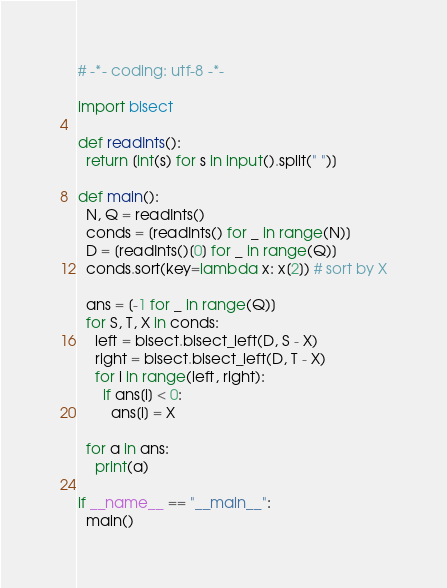Convert code to text. <code><loc_0><loc_0><loc_500><loc_500><_Python_># -*- coding: utf-8 -*-

import bisect

def readInts():
  return [int(s) for s in input().split(" ")]

def main():
  N, Q = readInts()
  conds = [readInts() for _ in range(N)]
  D = [readInts()[0] for _ in range(Q)]
  conds.sort(key=lambda x: x[2]) # sort by X

  ans = [-1 for _ in range(Q)]
  for S, T, X in conds:
    left = bisect.bisect_left(D, S - X)
    right = bisect.bisect_left(D, T - X)
    for i in range(left, right):
      if ans[i] < 0:
        ans[i] = X

  for a in ans:
    print(a)

if __name__ == "__main__":
  main()
</code> 